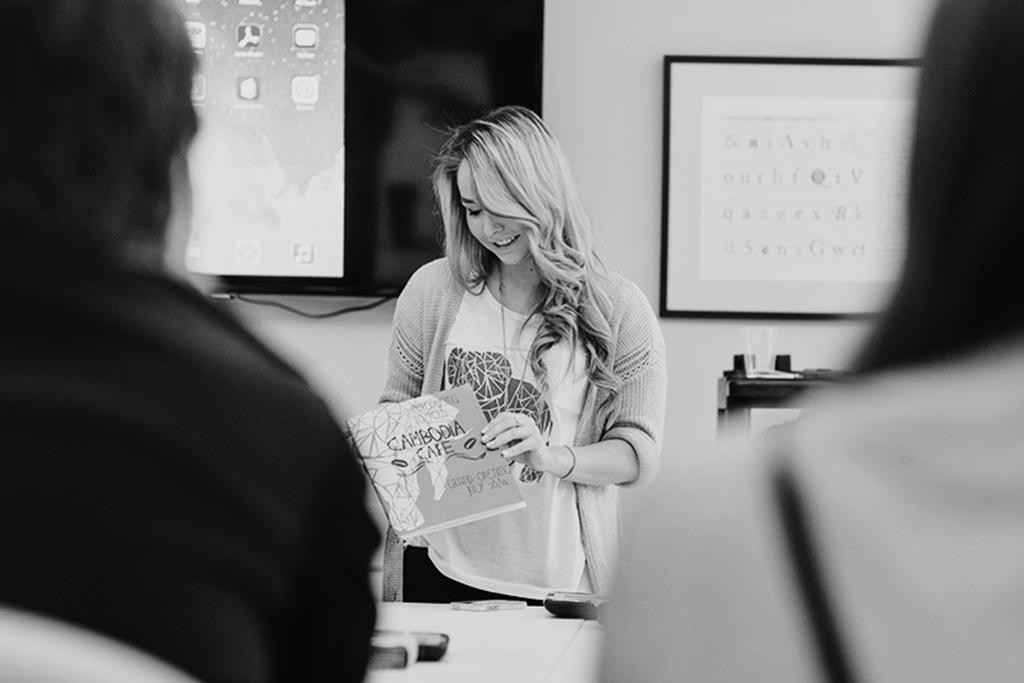Can you describe this image briefly? In the picture I can see a woman standing and holding a book in her hands and there are two persons in front of her and there are two projected images in the background. 